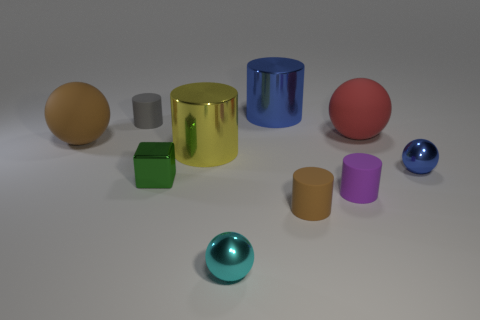There is a shiny cylinder in front of the brown rubber sphere; what is its size?
Keep it short and to the point. Large. Are there the same number of blue spheres to the left of the small cyan shiny ball and green shiny cubes?
Your answer should be very brief. No. Are there any cyan objects that have the same shape as the small purple rubber thing?
Your response must be concise. No. What is the shape of the tiny metal thing that is both behind the small cyan shiny ball and on the left side of the tiny blue shiny thing?
Your answer should be compact. Cube. Do the red thing and the small thing that is on the left side of the tiny metal block have the same material?
Make the answer very short. Yes. Are there any objects in front of the small gray thing?
Give a very brief answer. Yes. How many objects are large red matte spheres or small shiny things in front of the blue ball?
Provide a short and direct response. 3. The object that is behind the small cylinder that is on the left side of the small cube is what color?
Provide a succinct answer. Blue. How many other things are the same material as the small blue thing?
Give a very brief answer. 4. What number of matte objects are either blue cylinders or tiny brown things?
Offer a very short reply. 1. 